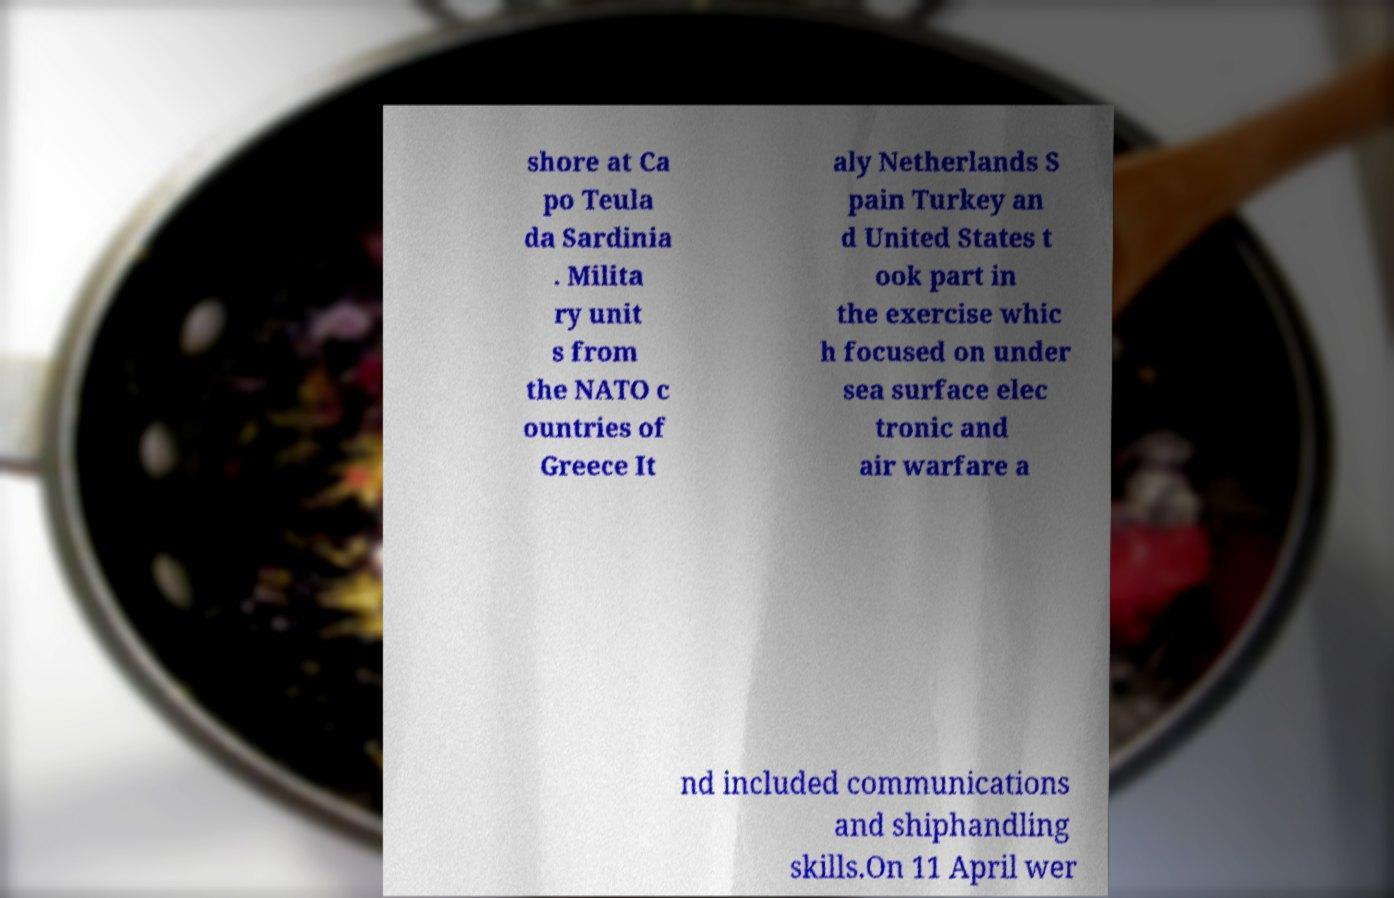Please identify and transcribe the text found in this image. shore at Ca po Teula da Sardinia . Milita ry unit s from the NATO c ountries of Greece It aly Netherlands S pain Turkey an d United States t ook part in the exercise whic h focused on under sea surface elec tronic and air warfare a nd included communications and shiphandling skills.On 11 April wer 